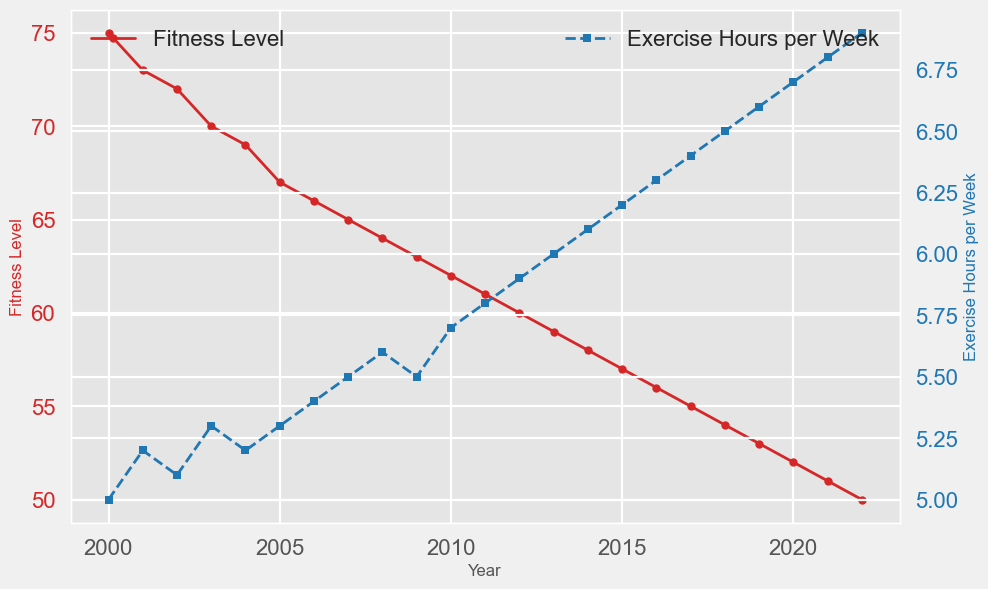- How has the fitness level of retired football players changed from 2000 to 2022? To find this, look at the line representing 'Fitness Level' from 2000 to 2022. The line consistently declines over the years.
Answer: It has decreased - By how many points has the fitness level decreased from 2000 to 2022? The fitness level in 2000 was 75 and in 2022, it was 50. Subtract 50 from 75 to get the difference. 75 - 50 = 25.
Answer: 25 points - Which year marks the highest exercise hours per week, and what is the value? Look for the peak in the 'Exercise Hours per Week' line on the chart. The highest value is 6.9 hours in 2022.
Answer: 2022, 6.9 - How did exercise hours per week change between 2000 and 2010? To determine this, track the 'Exercise Hours per Week' line between these years. It starts at 5 hours in 2000 and increases to 5.7 in 2010.
Answer: Increased by 0.7 hours - In which year did the exercise hours per week surpass the 6-hour mark? Observe the 'Exercise Hours per Week' line and identify the point where it first goes above 6. That happens in 2013.
Answer: 2013 - Compare the rates of change in fitness levels between 2000-2011 and 2011-2022. Which period showed a faster decline? Calculate the decline in each period. From 2000 (75) to 2011 (61), it's 75-61=14. From 2011 (61) to 2022 (50), it's 61-50=11. Divide by the number of years in each period to get the rate. 14/11 = 1.27 per year for 2000-2011 and 11/11 = 1 per year for 2011-2022.
Answer: 2000-2011 showed a faster decline - What is the trend in exercise hours per week over the years? Observe the 'Exercise Hours per Week' line from start to end. The line consistently rises, indicating an increasing trend.
Answer: Increasing - Determine the average fitness level over the entire period from 2000 to 2022. Add up all the fitness levels and divide by the number of years. (75+73+72+70+69+67+66+65+64+63+62+61+60+59+58+57+56+55+54+53+52+51+50)/23 = 62.26
Answer: 62.26 - Which year saw the smallest difference between fitness levels and exercise hours per week? To find this, look for the year where the gap between the 'Fitness Level' and 'Exercise Hours per Week' values is the smallest.
Answer: There is no specific year where this difference is directly indicated to be the smallest from the chart alone - By how much did exercise hours per week increase from 2015 to 2022? In 2015, exercise hours per week were 6.2 and in 2022, it was 6.9. Subtract 6.2 from 6.9 to find the increase. 6.9 - 6.2 = 0.7.
Answer: 0.7 hours 